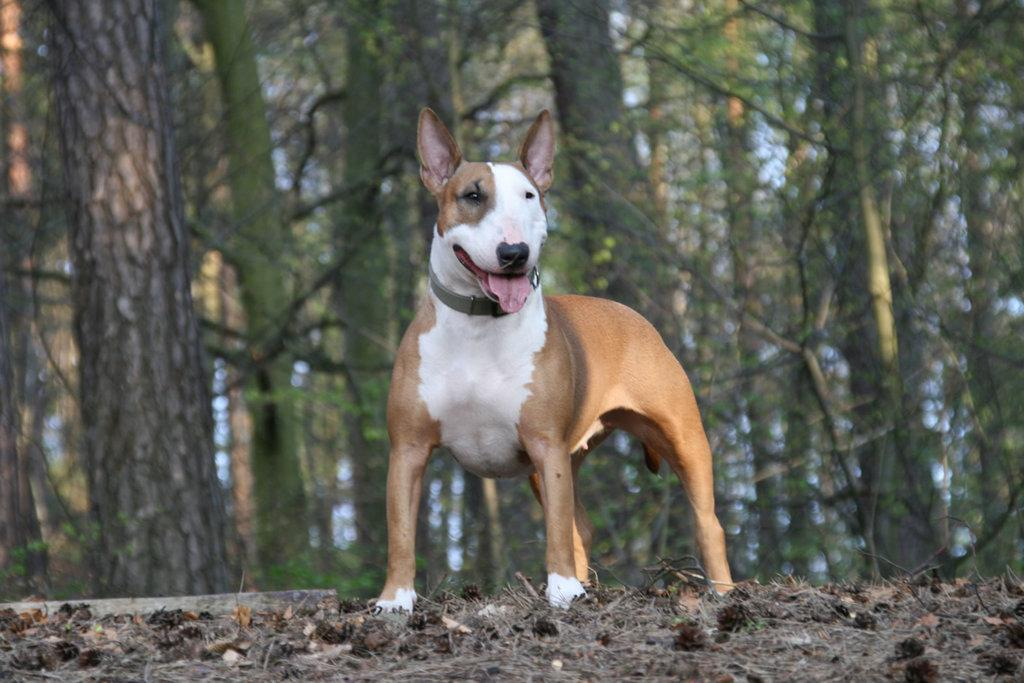What is the main subject in the center of the image? There is a dog in the center of the image. What can be seen in the background of the image? There are trees in the background of the image. What is the nature of the scrap visible at the bottom of the image? There is some scrap visible at the bottom of the image. What type of drain is visible in the image? There is no drain present in the image. Is there a carriage in the image? No, there is no carriage present in the image. 